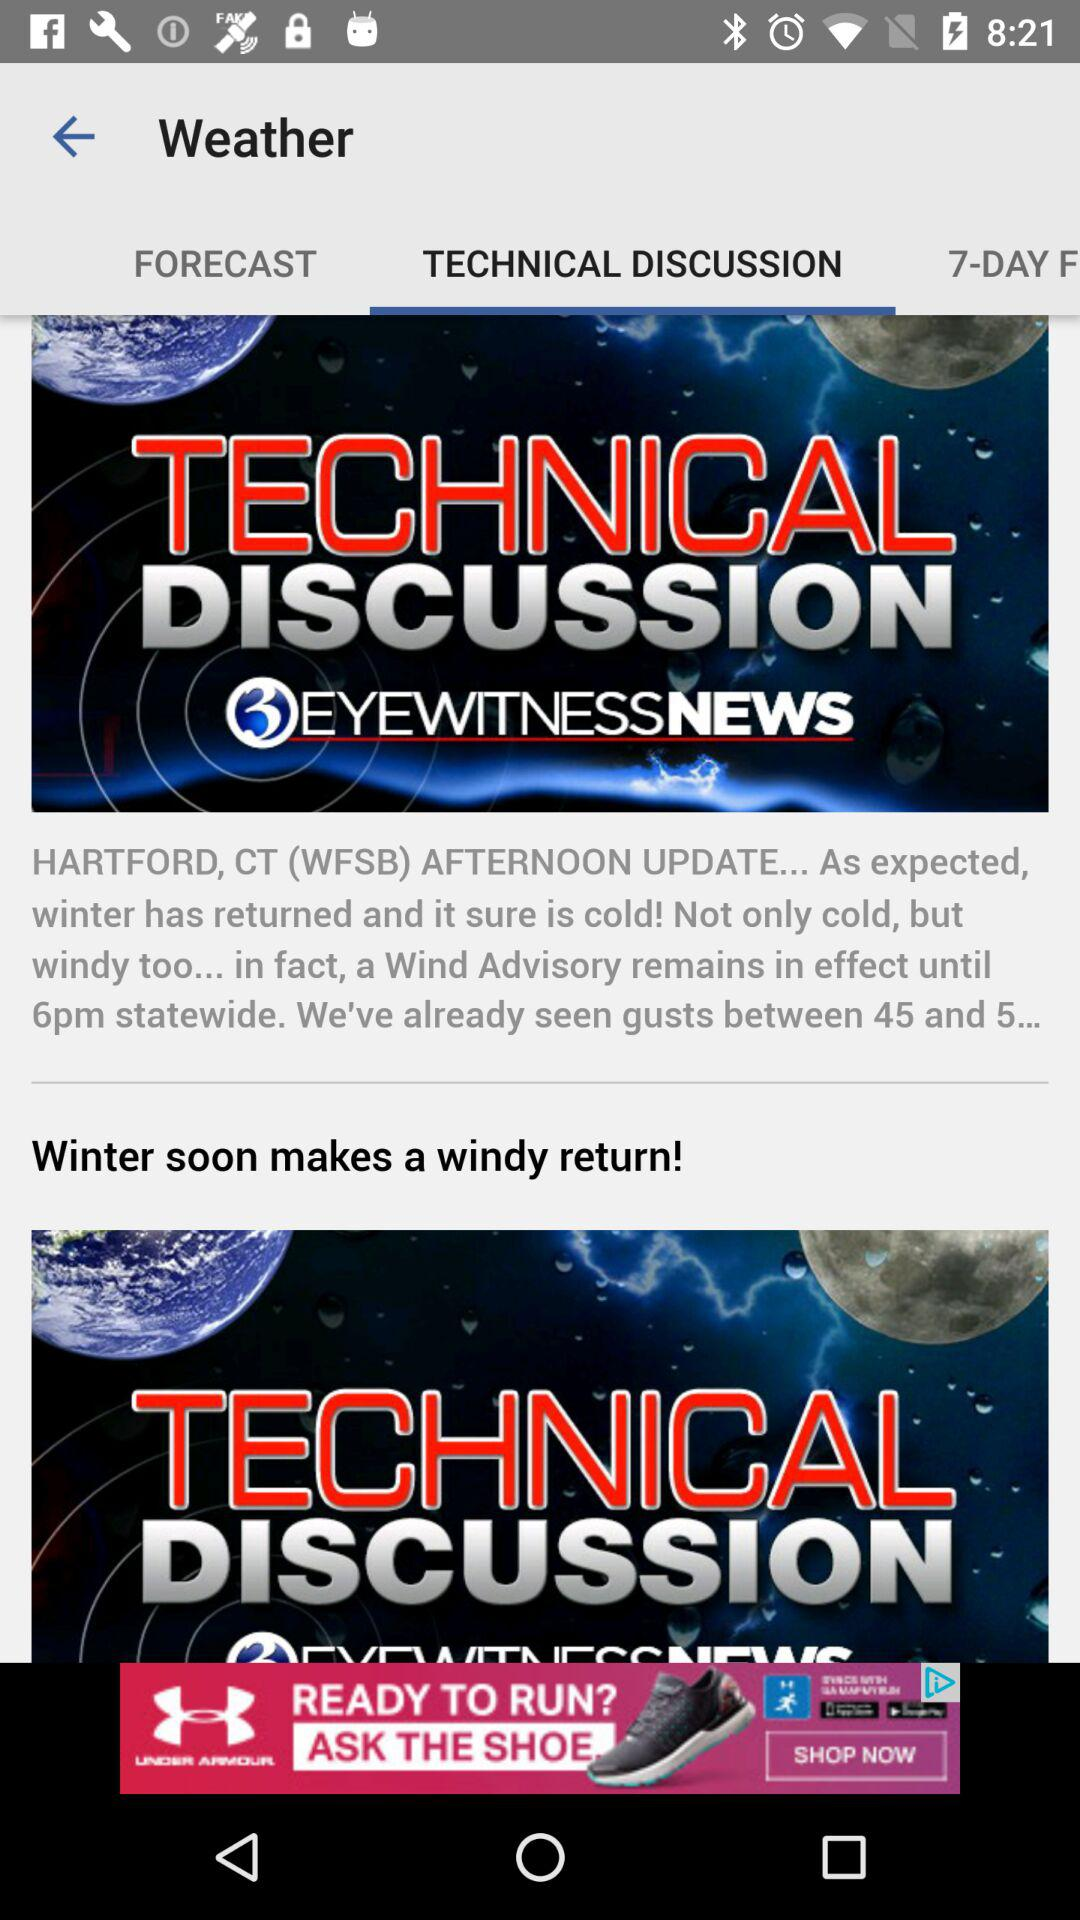Until when will the wind advisory remain in effect? The wind advisory will remain in effect until 6 p.m. 